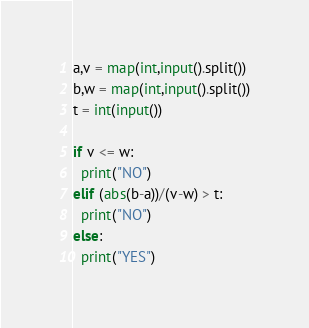<code> <loc_0><loc_0><loc_500><loc_500><_Python_>a,v = map(int,input().split())
b,w = map(int,input().split())
t = int(input())

if v <= w:
  print("NO")
elif (abs(b-a))/(v-w) > t:
  print("NO")
else:
  print("YES")</code> 